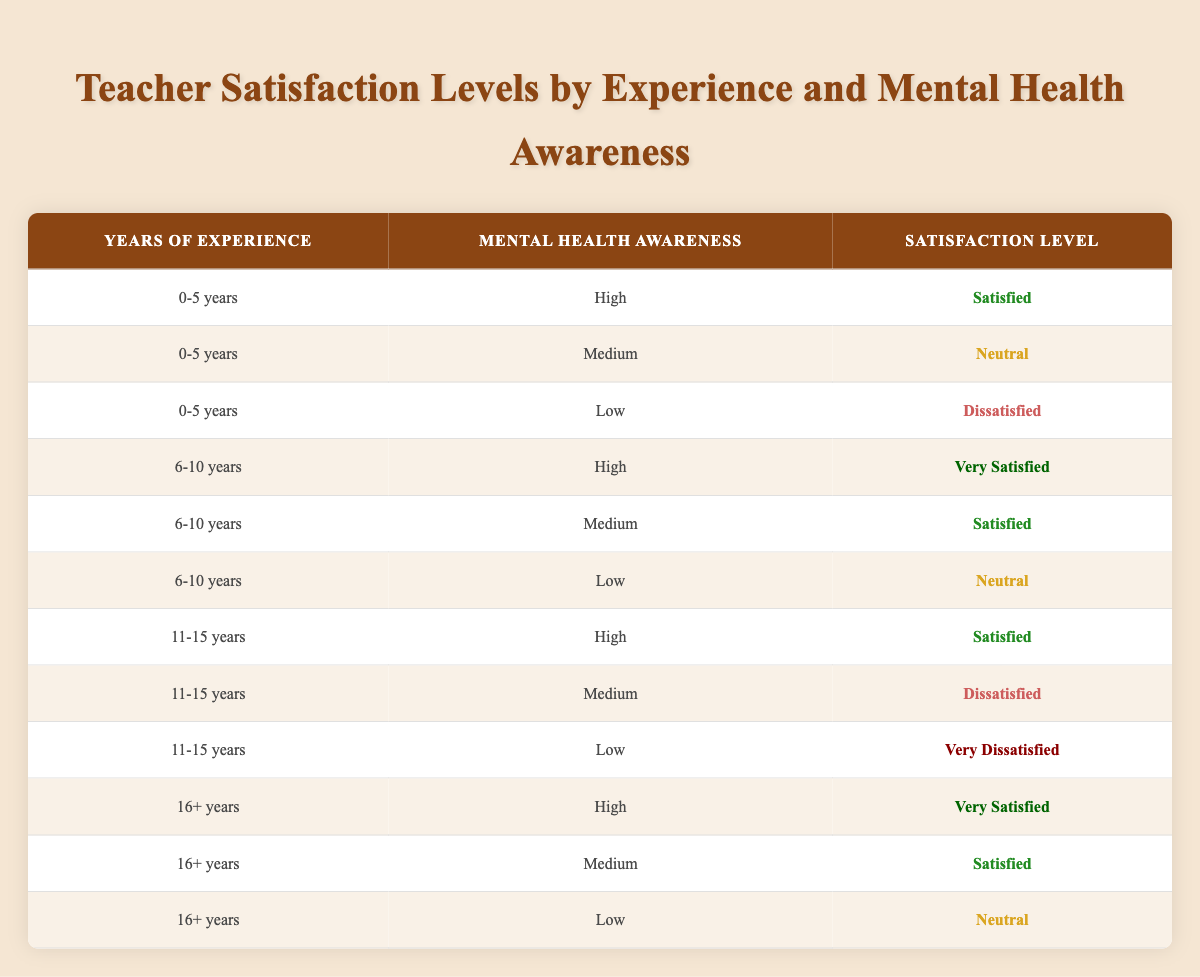What is the satisfaction level of teachers with 11-15 years of experience and high mental health awareness? According to the table, there is a row with "11-15 years" in the "Years of Experience" column and "High" in the "Mental Health Awareness" column. The corresponding "Satisfaction Level" in that row is "Satisfied."
Answer: Satisfied How many teachers are satisfied with their job who have 6-10 years of experience? From the table, there are two rows for teachers with "6-10 years" of experience: one with "High" mental health awareness, which is "Very Satisfied," and one with "Medium" mental health awareness, which is "Satisfied." Thus, the total number of satisfied teachers in this experience range is 2.
Answer: 2 Is it true that teachers with low mental health awareness have the highest level of dissatisfaction? By reviewing the satisfaction levels of teachers with low awareness: "0-5 years" shows "Dissatisfied," "6-10 years" shows "Neutral," "11-15 years" shows "Very Dissatisfied," and "16+ years" shows "Neutral." Since "11-15 years" has "Very Dissatisfied," it is the highest level of dissatisfaction, making the statement true.
Answer: Yes What is the total number of 'Very Satisfied' teachers among those with 16+ years of experience and high mental health awareness? The table indicates one row showing "16+ years" and "High" mental health awareness with a satisfaction level of "Very Satisfied." Therefore, the total is 1.
Answer: 1 What proportion of teachers with 0-5 years of experience rated their satisfaction as 'Dissatisfied'? There are three entries for teachers with "0-5 years": "High" is "Satisfied," "Medium" is "Neutral," and "Low" is "Dissatisfied." Hence, there is one "Dissatisfied" entry out of three total, leading to a proportion of 1/3 or approximately 33.33%.
Answer: 1/3 or 33.33% How does the satisfaction level change for teachers with 11-15 years of experience as their mental health awareness decreases from high to low? For teachers with "11-15 years," the satisfaction level is "Satisfied" at high awareness, "Dissatisfied" at medium awareness, and "Very Dissatisfied" at low awareness. This shows a downward trend in satisfaction as mental health awareness decreases.
Answer: Decreases Is the satisfaction level 'Neutral' for teachers with 0-5 years and low mental health awareness? Reviewing the table for "0-5 years" combined with "Low" mental health awareness indeed shows "Dissatisfied," so this statement is false.
Answer: No What is the average satisfaction level for teachers with 6-10 years of experience? The satisfaction levels for "6-10 years" are "Very Satisfied," "Satisfied," and "Neutral." Mapping them to values (very satisfied=4, satisfied=3, neutral=2), we get (4 + 3 + 2) / 3 = 3, leading to the average being "Satisfied."
Answer: Satisfied 